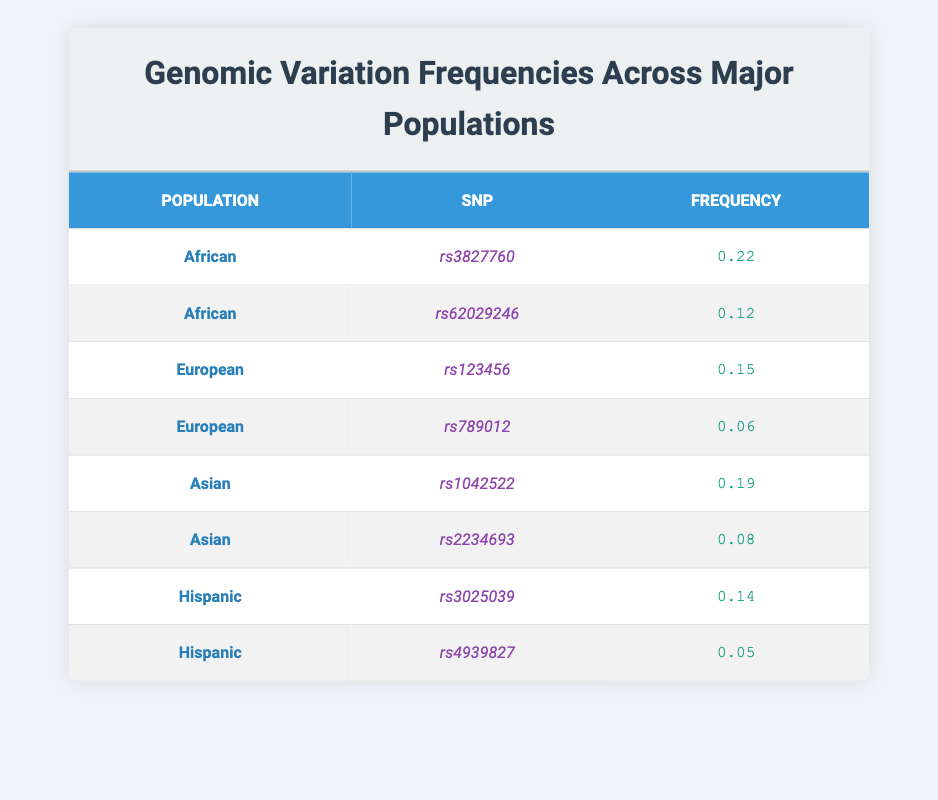What is the frequency of SNP rs3827760 in the African population? The table lists the SNP rs3827760 under the African population, where its frequency is specified as 0.22.
Answer: 0.22 Which population has the lowest frequency for SNP rs789012? The SNP rs789012 is listed under the European population with a frequency of 0.06, and no other populations have a lower frequency for this SNP in the table.
Answer: European What is the average frequency of SNPs in the Hispanic population? The frequencies for Hispanic SNPs are 0.14 (rs3025039) and 0.05 (rs4939827). To find the average, sum these values: 0.14 + 0.05 = 0.19, then divide by 2: 0.19 / 2 = 0.095.
Answer: 0.095 Is the frequency of SNP rs2234693 higher than that of SNP rs3025039? SNP rs2234693 is listed under the Asian population with a frequency of 0.08, while SNP rs3025039 under the Hispanic population has a frequency of 0.14. Since 0.08 is not greater than 0.14, the statement is false.
Answer: No Which population has the highest overall SNP frequency, and what is that value? The table shows that the highest frequency is 0.22 for the African population (rs3827760). Checking other populations, the next highest is 0.19 for the Asian population (rs1042522), which is lower than 0.22.
Answer: African, 0.22 What is the total frequency of all SNPs listed for the Asian population? For the Asian population, the SNP frequencies are 0.19 (rs1042522) and 0.08 (rs2234693). Adding these together: 0.19 + 0.08 = 0.27.
Answer: 0.27 Does the European population have more SNPs listed than the Asian population? The European population has 2 SNPs (rs123456 and rs789012), whereas the Asian population also has 2 SNPs (rs1042522 and rs2234693). Therefore, both populations have an equal number of SNPs, making the statement false.
Answer: No Which SNP has the highest frequency in the table overall, and what is that frequency? By comparing all the frequencies in the table, rs3827760 (0.22 in the African population) has the highest frequency compared to other SNPs.
Answer: rs3827760, 0.22 